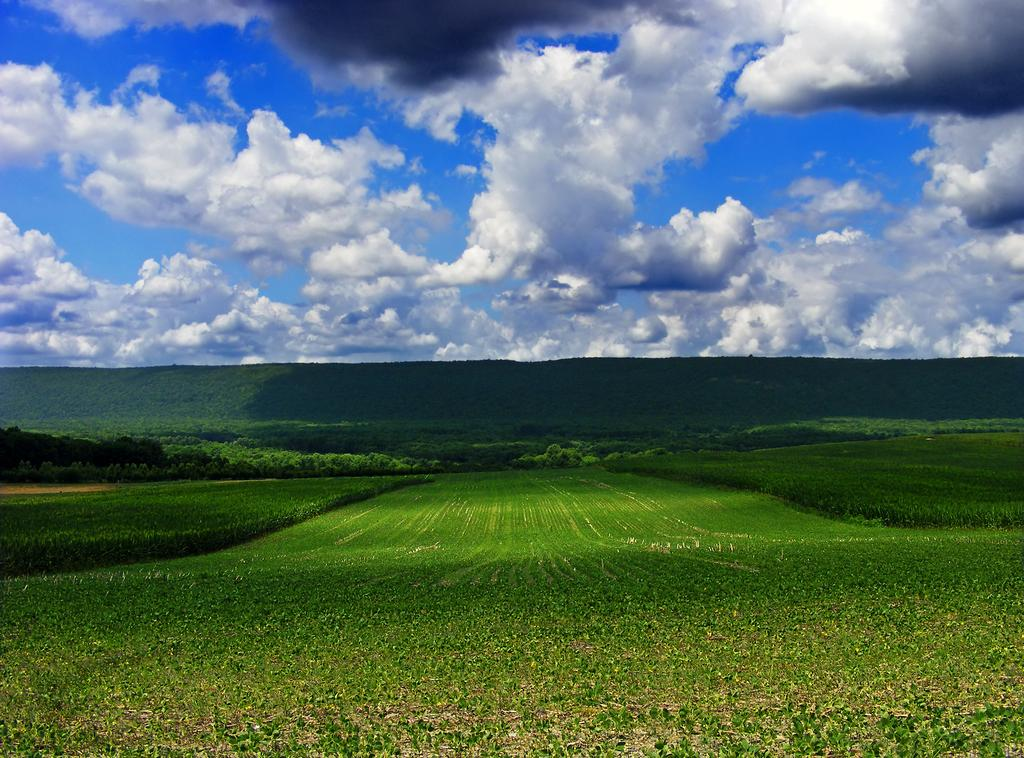What type of natural environment is visible at the bottom side of the image? There is greenery at the bottom side of the image. What is visible at the top side of the image? There is sky at the top side of the image. How many dolls are sitting on the person's chin in the image? There are no dolls or people present in the image, so it is not possible to answer that question. 